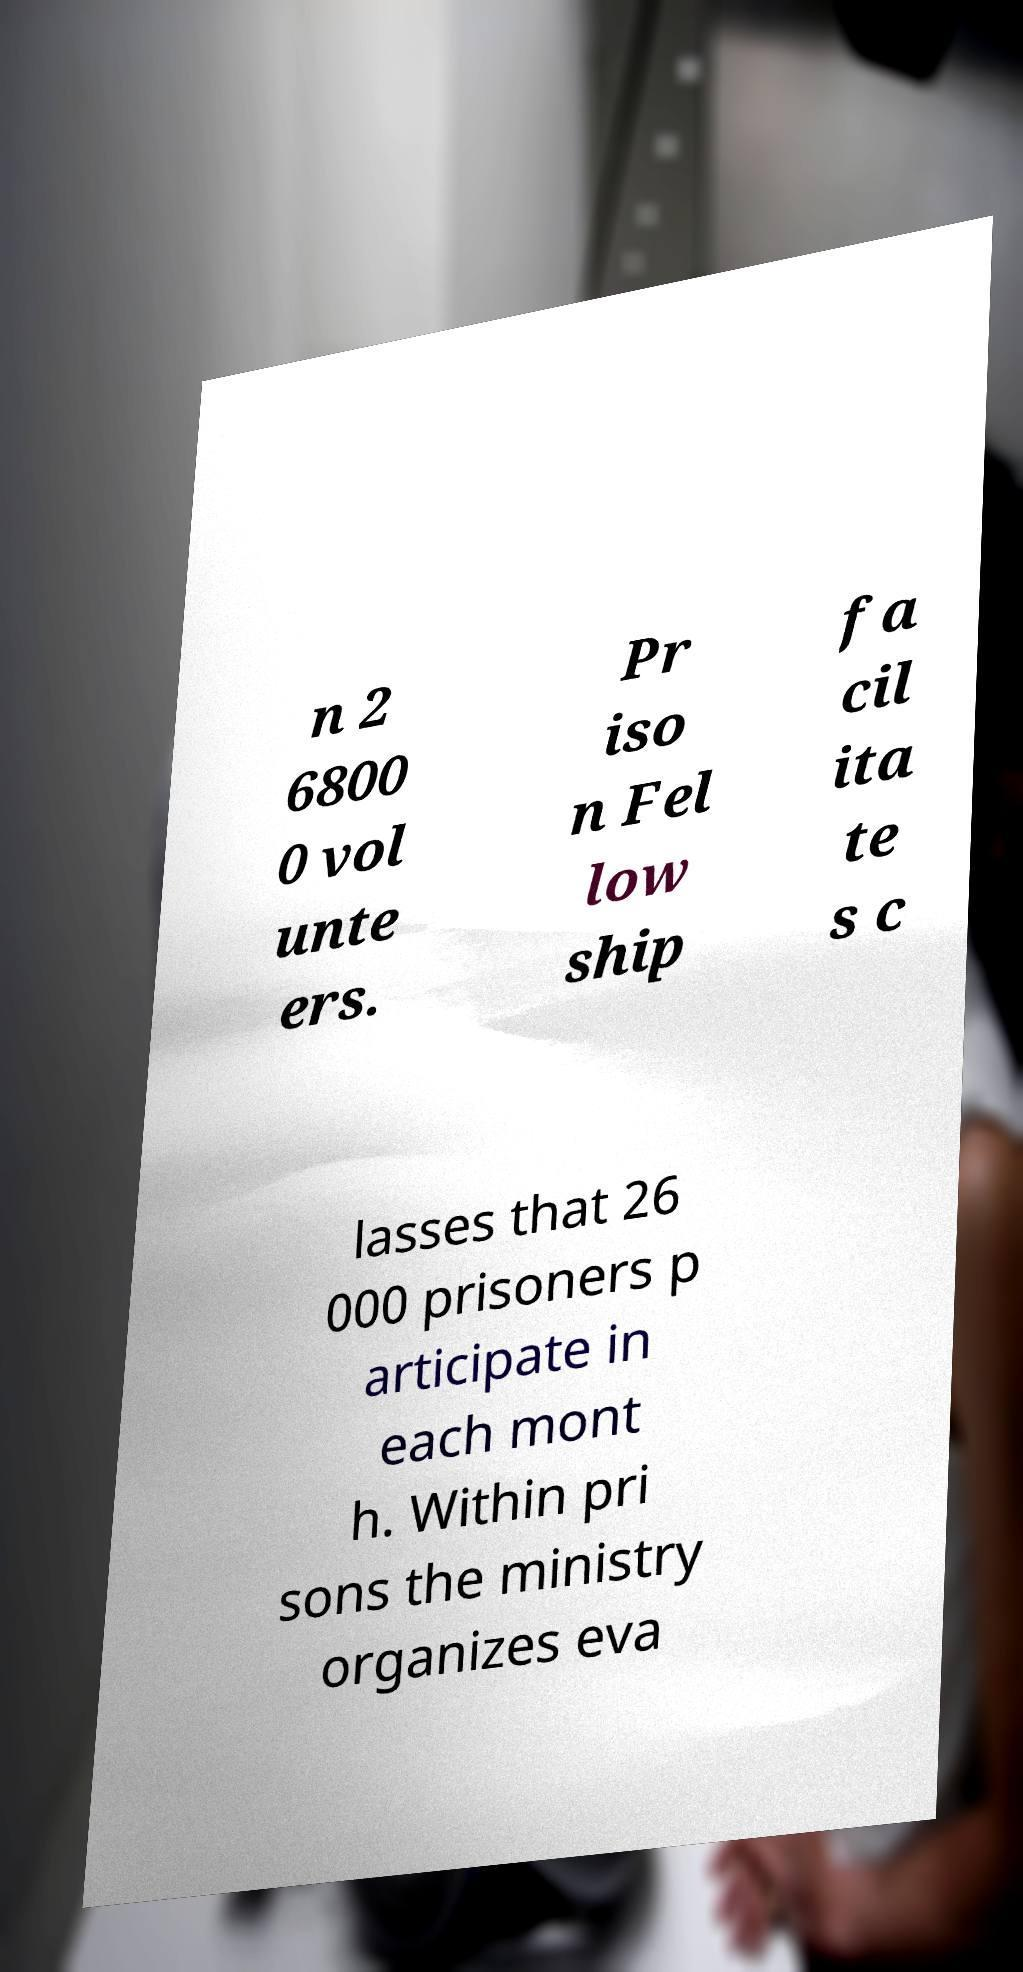What messages or text are displayed in this image? I need them in a readable, typed format. n 2 6800 0 vol unte ers. Pr iso n Fel low ship fa cil ita te s c lasses that 26 000 prisoners p articipate in each mont h. Within pri sons the ministry organizes eva 